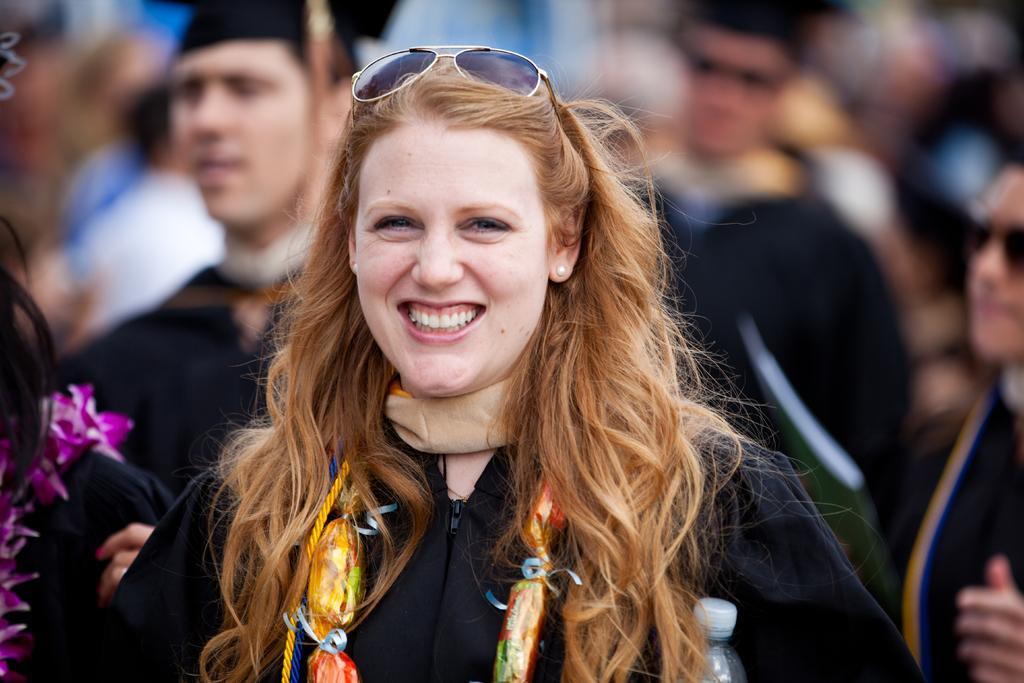In one or two sentences, can you explain what this image depicts? In this picture there is a woman wearing black dress is smiling and there are few other persons wearing graduation dress behind her. 